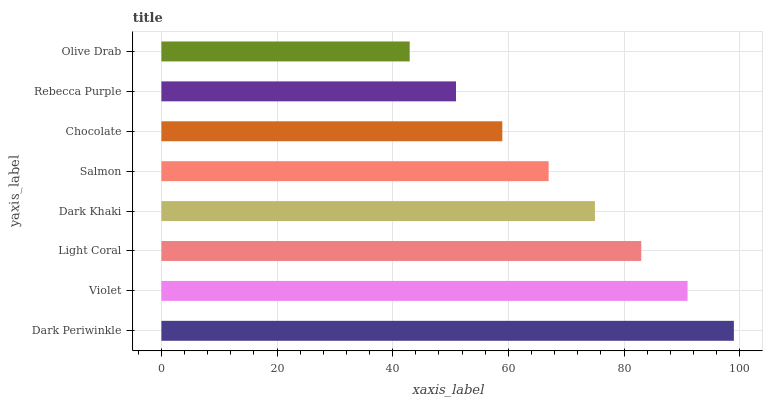Is Olive Drab the minimum?
Answer yes or no. Yes. Is Dark Periwinkle the maximum?
Answer yes or no. Yes. Is Violet the minimum?
Answer yes or no. No. Is Violet the maximum?
Answer yes or no. No. Is Dark Periwinkle greater than Violet?
Answer yes or no. Yes. Is Violet less than Dark Periwinkle?
Answer yes or no. Yes. Is Violet greater than Dark Periwinkle?
Answer yes or no. No. Is Dark Periwinkle less than Violet?
Answer yes or no. No. Is Dark Khaki the high median?
Answer yes or no. Yes. Is Salmon the low median?
Answer yes or no. Yes. Is Violet the high median?
Answer yes or no. No. Is Light Coral the low median?
Answer yes or no. No. 